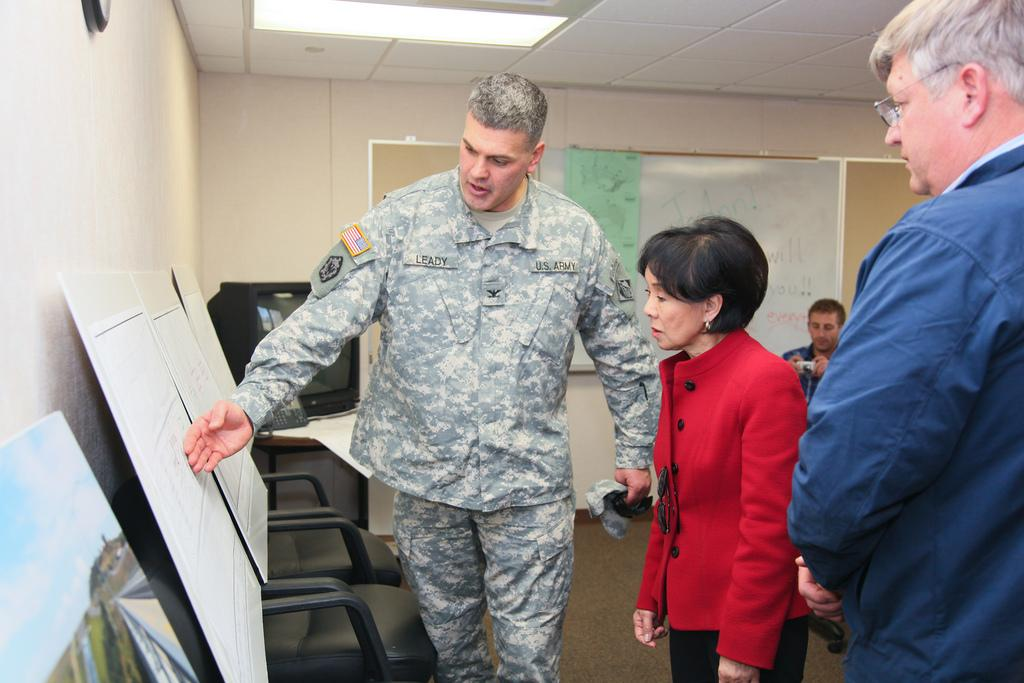Who or what can be seen in the image? There are people in the image. What objects are present in the image that might be used for displaying information? There are display boards in the image. What is on the wall in the background of the image? There is a board on the wall in the background. What is on the left side of the image? There is a wall on the left side of the image. What type of flooring is visible in the image? There is a carpet in the image. What electronic device can be seen in the image? There is a TV in the image. What type of dress is the fuel wearing in the image? There is no fuel or dress present in the image. 